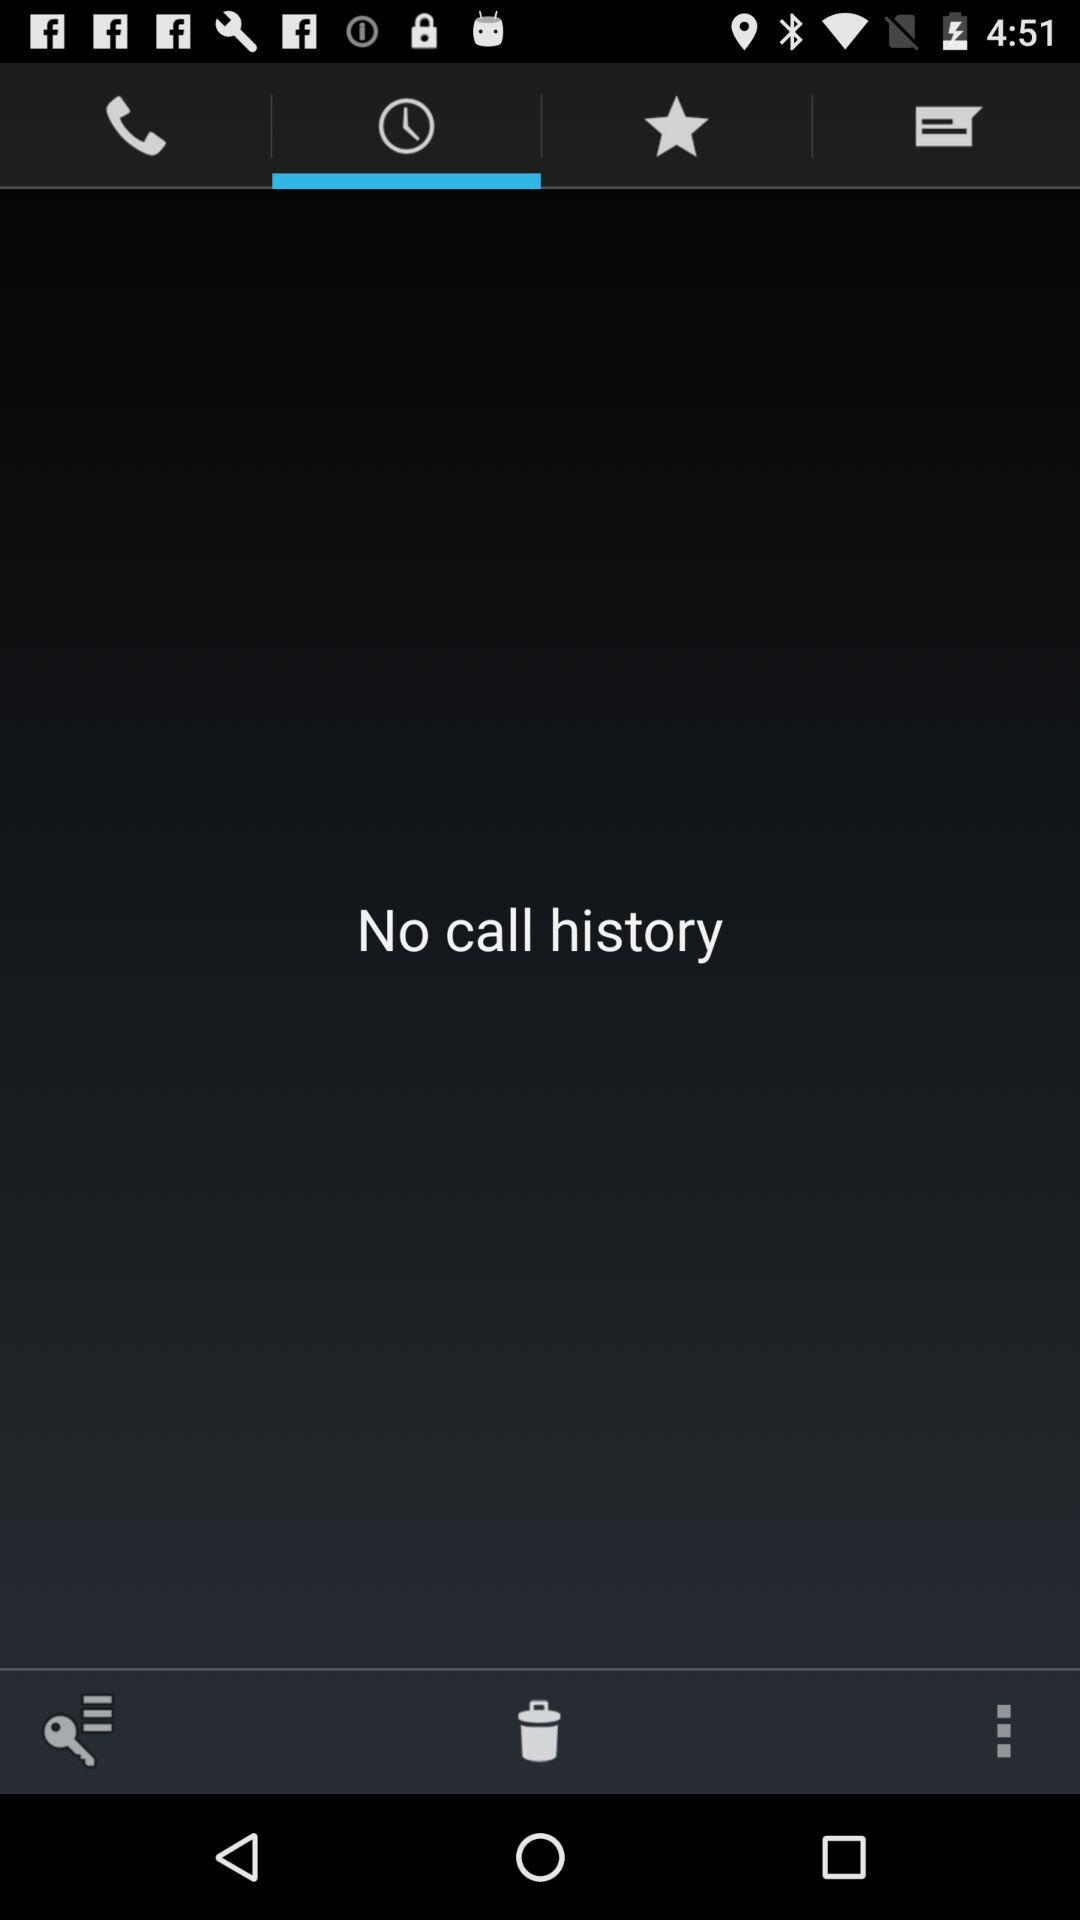Which tab has been selected? The selected tab is "Call history". 